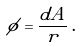Convert formula to latex. <formula><loc_0><loc_0><loc_500><loc_500>\phi = \frac { d A } { r } \, .</formula> 